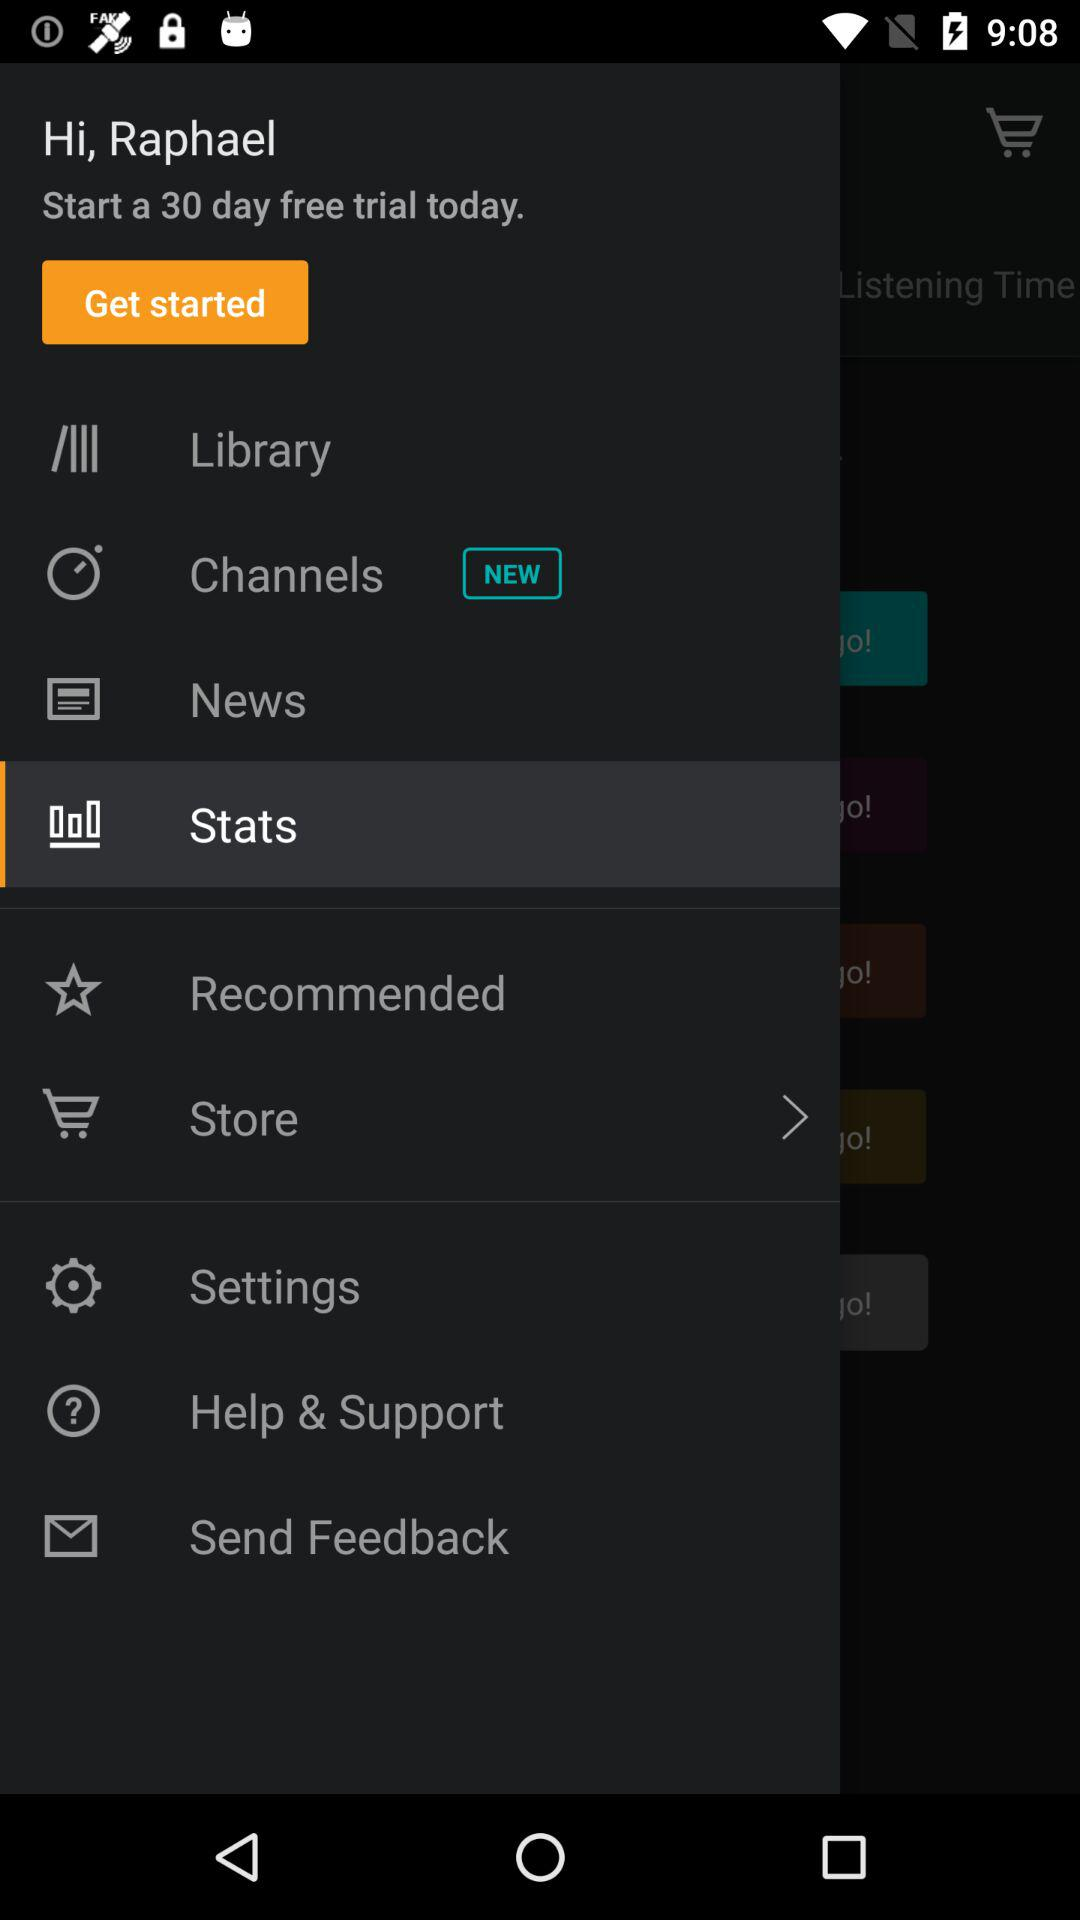What is the user name? The user name is Raphael. 